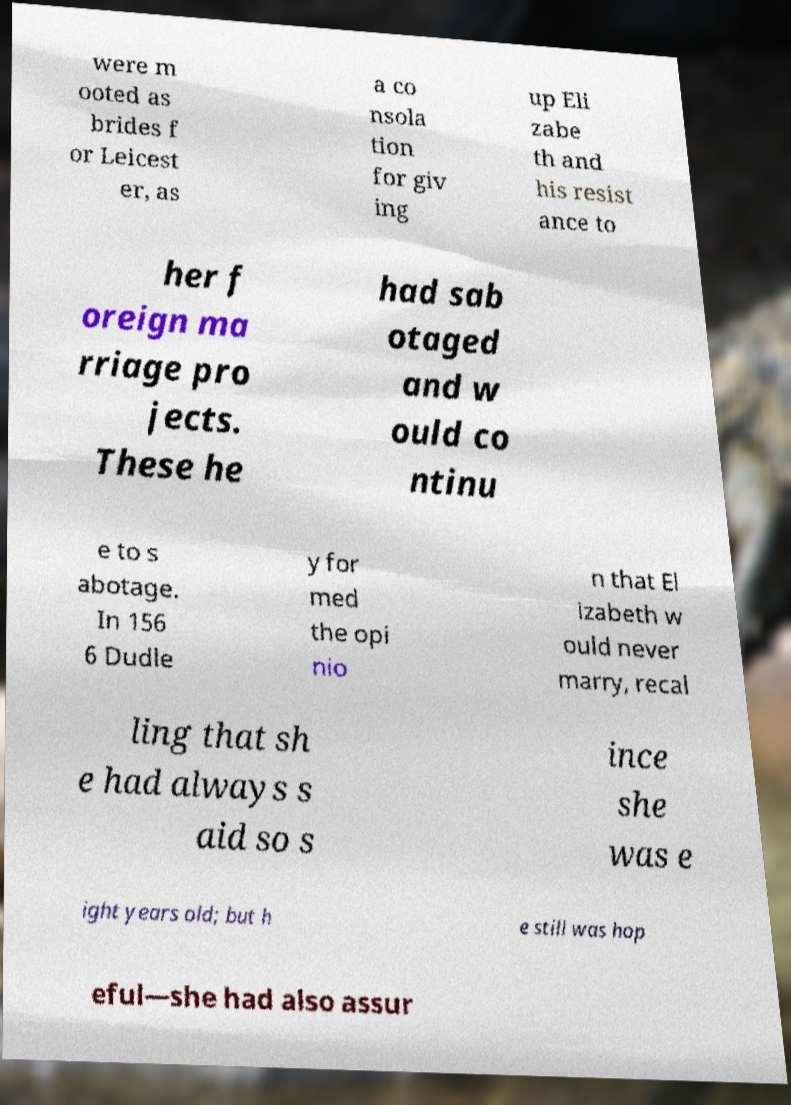There's text embedded in this image that I need extracted. Can you transcribe it verbatim? were m ooted as brides f or Leicest er, as a co nsola tion for giv ing up Eli zabe th and his resist ance to her f oreign ma rriage pro jects. These he had sab otaged and w ould co ntinu e to s abotage. In 156 6 Dudle y for med the opi nio n that El izabeth w ould never marry, recal ling that sh e had always s aid so s ince she was e ight years old; but h e still was hop eful—she had also assur 